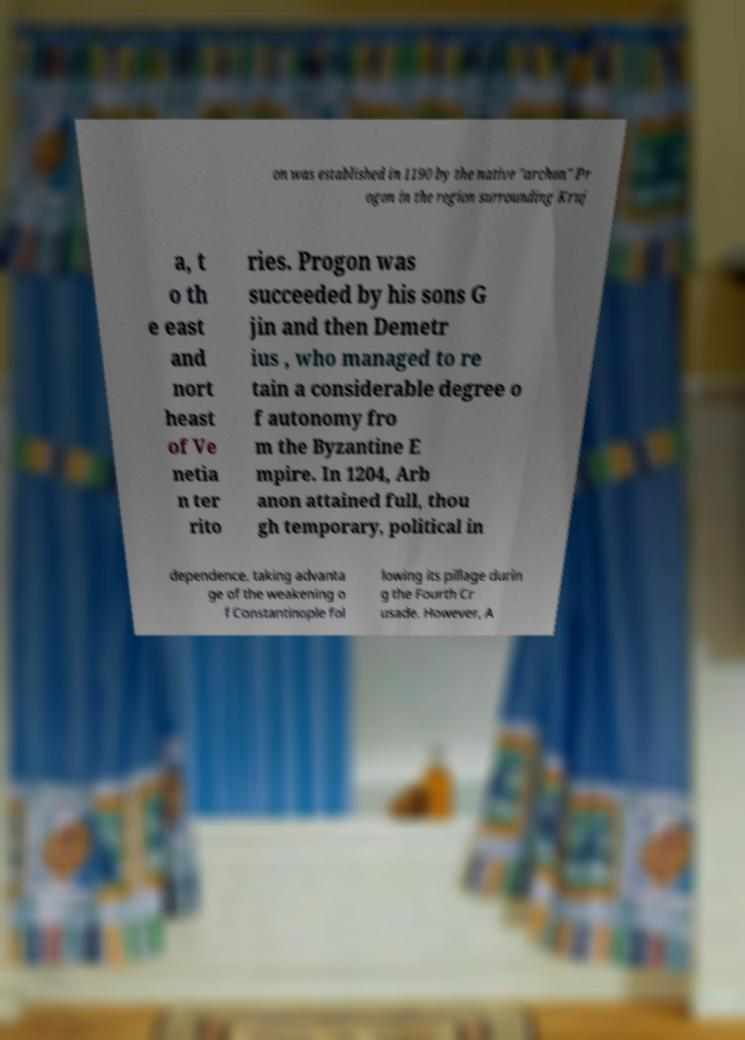There's text embedded in this image that I need extracted. Can you transcribe it verbatim? on was established in 1190 by the native "archon" Pr ogon in the region surrounding Kruj a, t o th e east and nort heast of Ve netia n ter rito ries. Progon was succeeded by his sons G jin and then Demetr ius , who managed to re tain a considerable degree o f autonomy fro m the Byzantine E mpire. In 1204, Arb anon attained full, thou gh temporary, political in dependence, taking advanta ge of the weakening o f Constantinople fol lowing its pillage durin g the Fourth Cr usade. However, A 